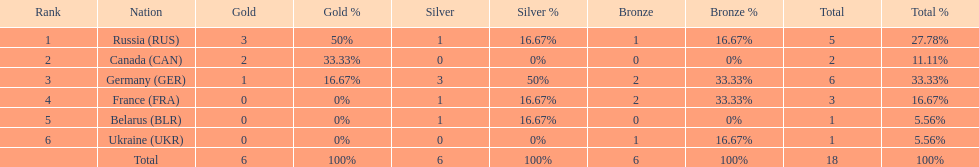Which country won more total medals than tue french, but less than the germans in the 1994 winter olympic biathlon? Russia. 